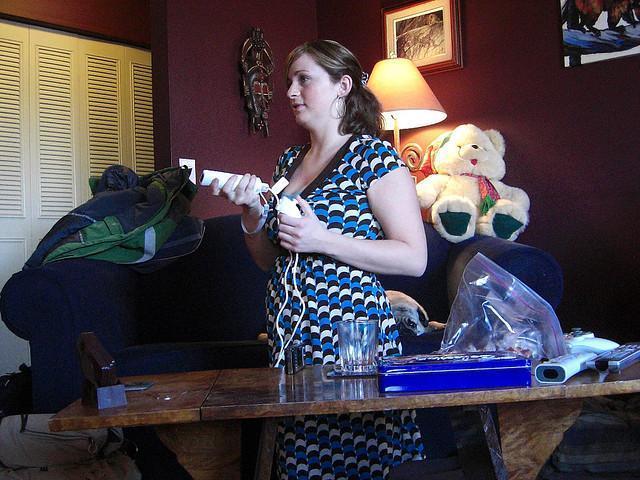How many couches are there?
Give a very brief answer. 2. How many dining tables are there?
Give a very brief answer. 1. 